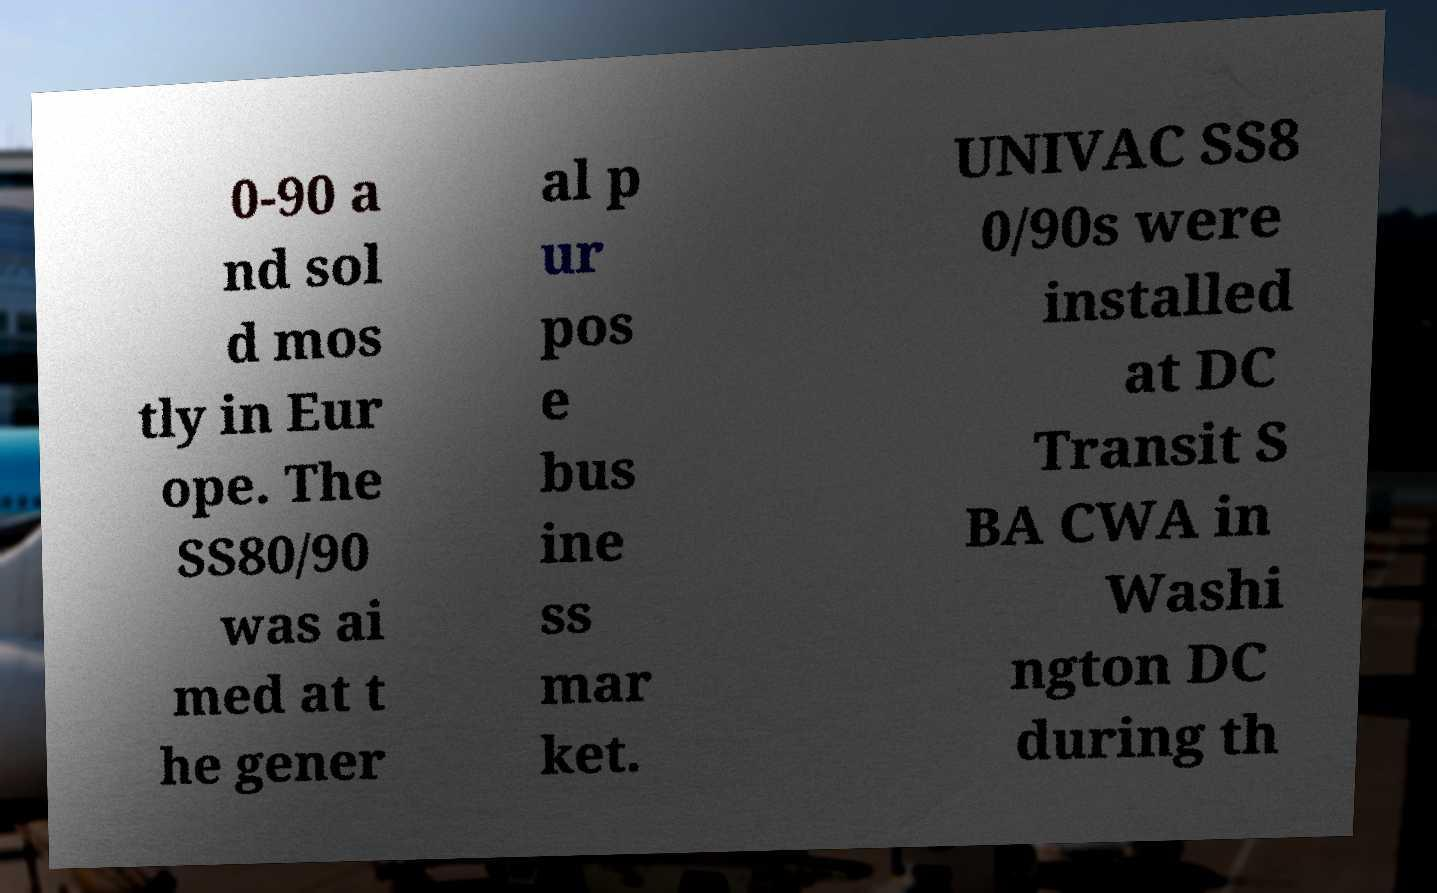Could you assist in decoding the text presented in this image and type it out clearly? 0-90 a nd sol d mos tly in Eur ope. The SS80/90 was ai med at t he gener al p ur pos e bus ine ss mar ket. UNIVAC SS8 0/90s were installed at DC Transit S BA CWA in Washi ngton DC during th 